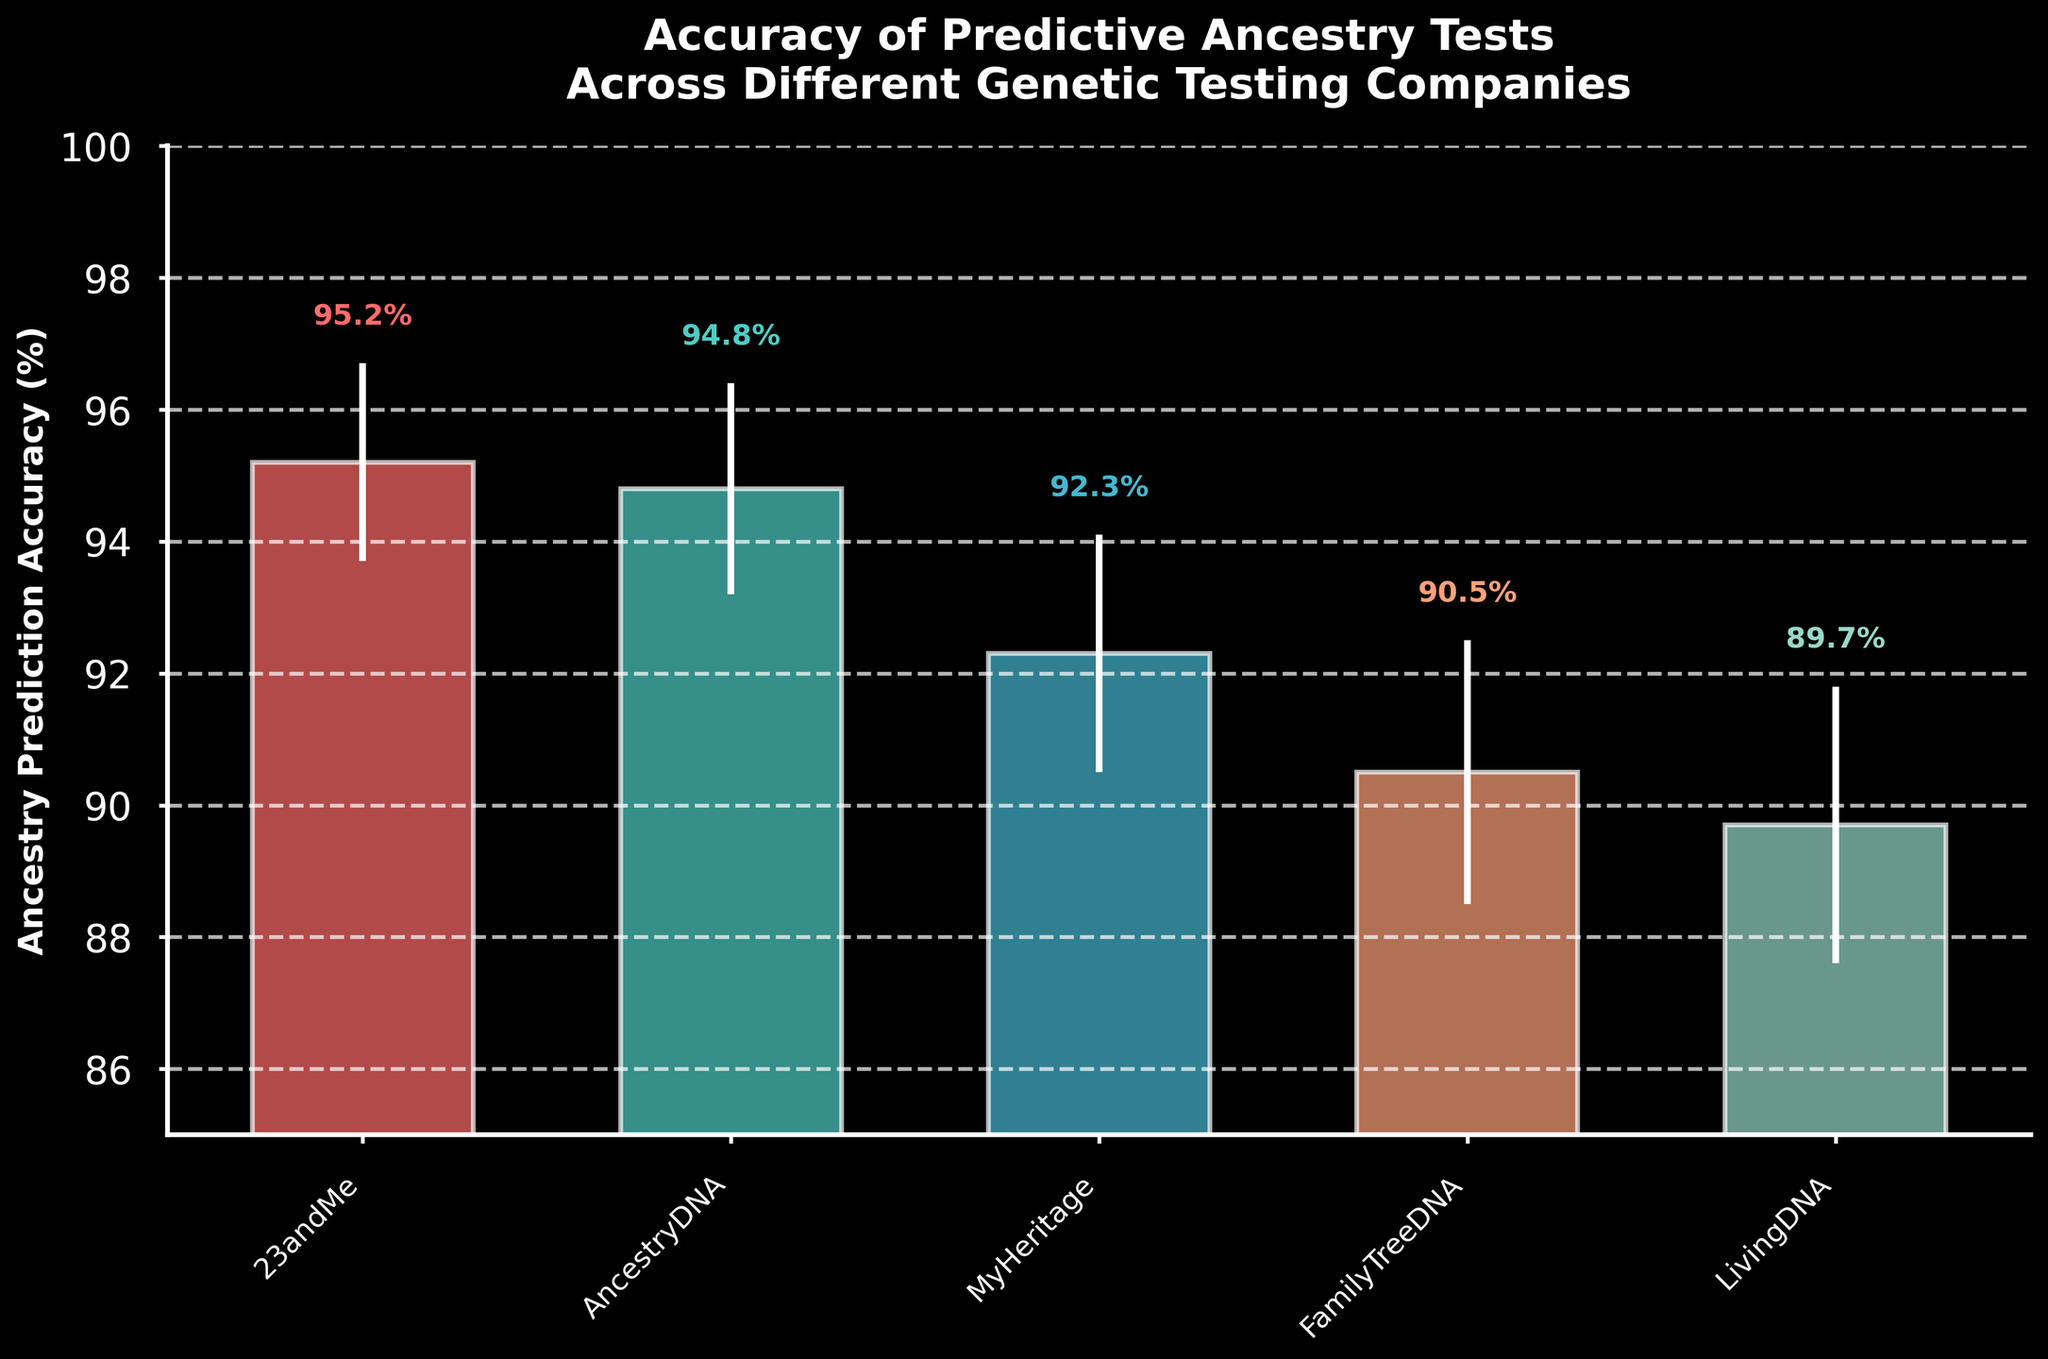What's the title of the figure? The title is given at the top of the figure, describing what the plot is about.
Answer: Accuracy of Predictive Ancestry Tests Across Different Genetic Testing Companies Which company has the highest ancestry prediction accuracy? The bar for 23andMe is the tallest, indicating it has the highest accuracy.
Answer: 23andMe What is the accuracy difference between the highest and lowest performing company? 23andMe has an accuracy of 95.2%, and LivingDNA has an accuracy of 89.7%. The difference is calculated by subtracting 89.7 from 95.2.
Answer: 5.5% What's the average accuracy of all the companies? Add all the accuracies (95.2 + 94.8 + 92.3 + 90.5 + 89.7) to get 462.5, then divide by the number of companies (5).
Answer: 92.5% Which company has the largest standard error, and what is its accuracy? The error bars show the uncertainty in the predictions. LivingDNA has the largest error bar (2.1), with an accuracy of 89.7%.
Answer: LivingDNA, 89.7% Which company has the smallest standard error, and what does this imply? 23andMe has the smallest error bar (1.5), which implies its prediction accuracy is more consistent compared to the others.
Answer: 23andMe What is the range of accuracies shown in the figure? The highest accuracy is 95.2% (23andMe) and the lowest is 89.7% (LivingDNA). The range is calculated by subtracting the lowest from the highest.
Answer: 5.5% How many companies have an accuracy above 90%? By observing the heights of the bars, 23andMe, AncestryDNA, MyHeritage, and FamilyTreeDNA all have accuracies above 90%.
Answer: 4 Which companies' accuracies are within 1% of each other? 23andMe (95.2%) and AncestryDNA (94.8%) have accuracies very close to each other, within 1%.
Answer: 23andMe and AncestryDNA What do the error bars represent in this figure? The error bars represent the standard error, indicating the variability or uncertainty around each company's ancestry prediction accuracy. Larger error bars suggest greater variability.
Answer: Standard error 